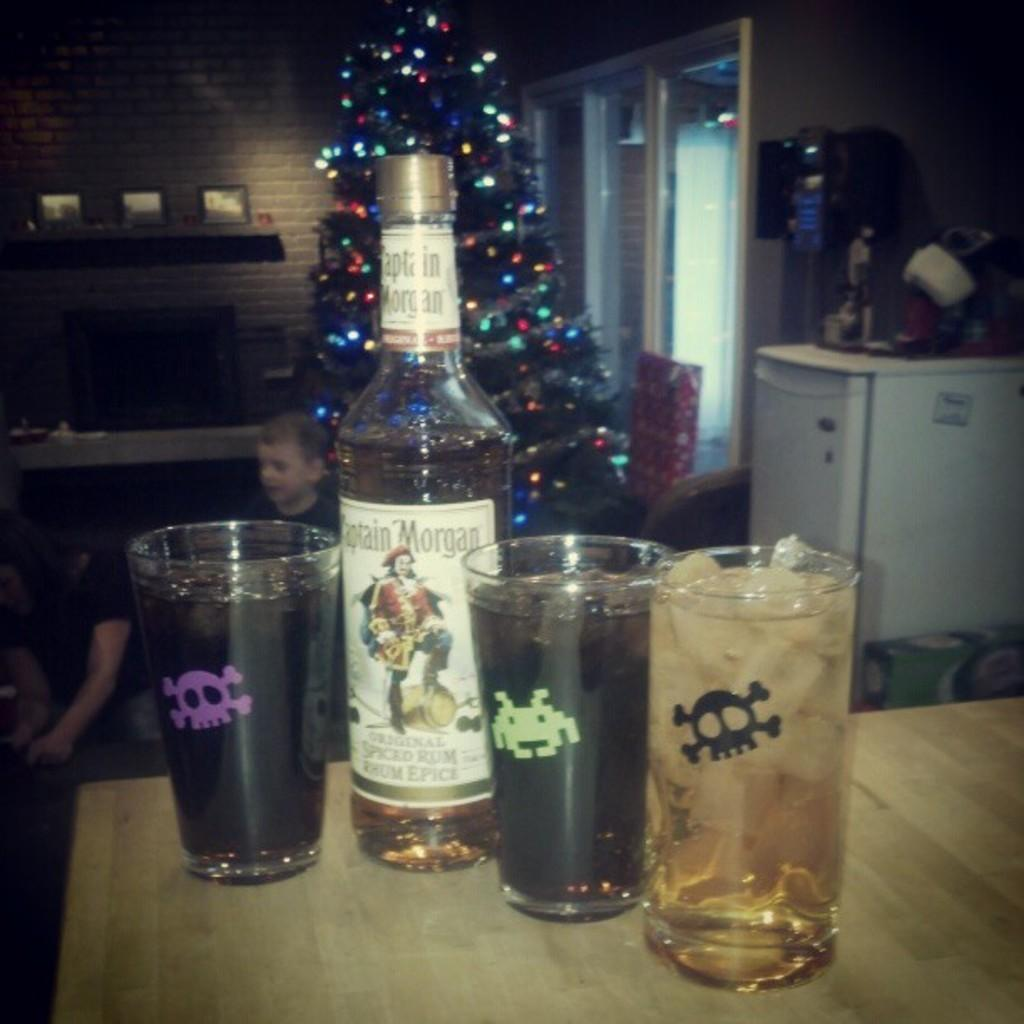Provide a one-sentence caption for the provided image. four glasses of alcohol and a bottle of Captain Morgan next to them on the table. 